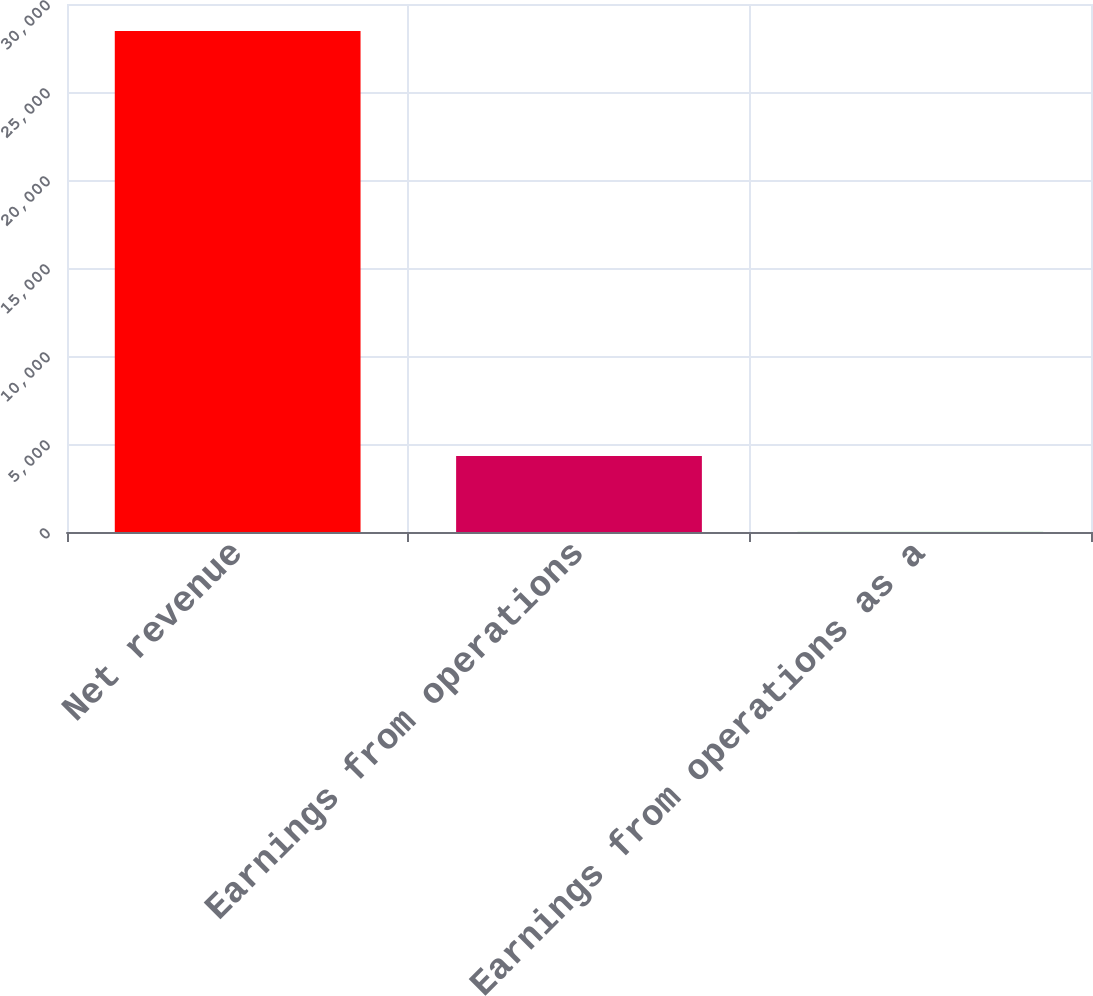Convert chart to OTSL. <chart><loc_0><loc_0><loc_500><loc_500><bar_chart><fcel>Net revenue<fcel>Earnings from operations<fcel>Earnings from operations as a<nl><fcel>28465<fcel>4315<fcel>15.2<nl></chart> 